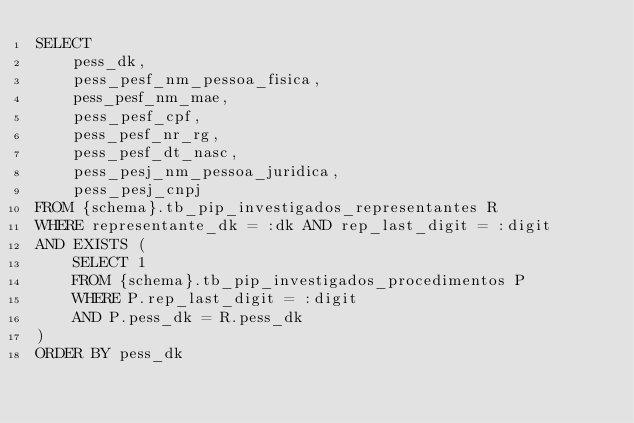Convert code to text. <code><loc_0><loc_0><loc_500><loc_500><_SQL_>SELECT
    pess_dk,
    pess_pesf_nm_pessoa_fisica,
    pess_pesf_nm_mae,
    pess_pesf_cpf,
    pess_pesf_nr_rg,
    pess_pesf_dt_nasc,
    pess_pesj_nm_pessoa_juridica,
    pess_pesj_cnpj
FROM {schema}.tb_pip_investigados_representantes R
WHERE representante_dk = :dk AND rep_last_digit = :digit
AND EXISTS (
    SELECT 1
    FROM {schema}.tb_pip_investigados_procedimentos P
    WHERE P.rep_last_digit = :digit
    AND P.pess_dk = R.pess_dk
)
ORDER BY pess_dk</code> 